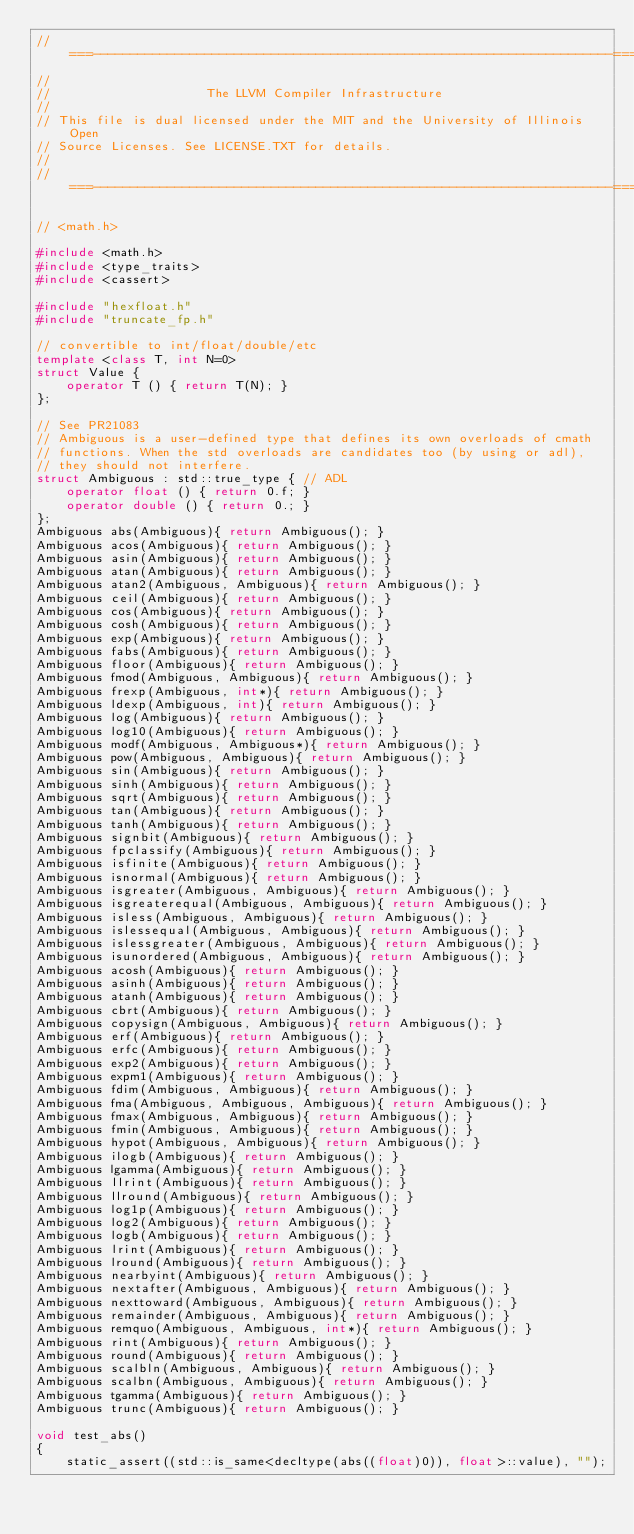<code> <loc_0><loc_0><loc_500><loc_500><_C++_>//===----------------------------------------------------------------------===//
//
//                     The LLVM Compiler Infrastructure
//
// This file is dual licensed under the MIT and the University of Illinois Open
// Source Licenses. See LICENSE.TXT for details.
//
//===----------------------------------------------------------------------===//

// <math.h>

#include <math.h>
#include <type_traits>
#include <cassert>

#include "hexfloat.h"
#include "truncate_fp.h"

// convertible to int/float/double/etc
template <class T, int N=0>
struct Value {
    operator T () { return T(N); }
};

// See PR21083
// Ambiguous is a user-defined type that defines its own overloads of cmath
// functions. When the std overloads are candidates too (by using or adl),
// they should not interfere.
struct Ambiguous : std::true_type { // ADL
    operator float () { return 0.f; }
    operator double () { return 0.; }
};
Ambiguous abs(Ambiguous){ return Ambiguous(); }
Ambiguous acos(Ambiguous){ return Ambiguous(); }
Ambiguous asin(Ambiguous){ return Ambiguous(); }
Ambiguous atan(Ambiguous){ return Ambiguous(); }
Ambiguous atan2(Ambiguous, Ambiguous){ return Ambiguous(); }
Ambiguous ceil(Ambiguous){ return Ambiguous(); }
Ambiguous cos(Ambiguous){ return Ambiguous(); }
Ambiguous cosh(Ambiguous){ return Ambiguous(); }
Ambiguous exp(Ambiguous){ return Ambiguous(); }
Ambiguous fabs(Ambiguous){ return Ambiguous(); }
Ambiguous floor(Ambiguous){ return Ambiguous(); }
Ambiguous fmod(Ambiguous, Ambiguous){ return Ambiguous(); }
Ambiguous frexp(Ambiguous, int*){ return Ambiguous(); }
Ambiguous ldexp(Ambiguous, int){ return Ambiguous(); }
Ambiguous log(Ambiguous){ return Ambiguous(); }
Ambiguous log10(Ambiguous){ return Ambiguous(); }
Ambiguous modf(Ambiguous, Ambiguous*){ return Ambiguous(); }
Ambiguous pow(Ambiguous, Ambiguous){ return Ambiguous(); }
Ambiguous sin(Ambiguous){ return Ambiguous(); }
Ambiguous sinh(Ambiguous){ return Ambiguous(); }
Ambiguous sqrt(Ambiguous){ return Ambiguous(); }
Ambiguous tan(Ambiguous){ return Ambiguous(); }
Ambiguous tanh(Ambiguous){ return Ambiguous(); }
Ambiguous signbit(Ambiguous){ return Ambiguous(); }
Ambiguous fpclassify(Ambiguous){ return Ambiguous(); }
Ambiguous isfinite(Ambiguous){ return Ambiguous(); }
Ambiguous isnormal(Ambiguous){ return Ambiguous(); }
Ambiguous isgreater(Ambiguous, Ambiguous){ return Ambiguous(); }
Ambiguous isgreaterequal(Ambiguous, Ambiguous){ return Ambiguous(); }
Ambiguous isless(Ambiguous, Ambiguous){ return Ambiguous(); }
Ambiguous islessequal(Ambiguous, Ambiguous){ return Ambiguous(); }
Ambiguous islessgreater(Ambiguous, Ambiguous){ return Ambiguous(); }
Ambiguous isunordered(Ambiguous, Ambiguous){ return Ambiguous(); }
Ambiguous acosh(Ambiguous){ return Ambiguous(); }
Ambiguous asinh(Ambiguous){ return Ambiguous(); }
Ambiguous atanh(Ambiguous){ return Ambiguous(); }
Ambiguous cbrt(Ambiguous){ return Ambiguous(); }
Ambiguous copysign(Ambiguous, Ambiguous){ return Ambiguous(); }
Ambiguous erf(Ambiguous){ return Ambiguous(); }
Ambiguous erfc(Ambiguous){ return Ambiguous(); }
Ambiguous exp2(Ambiguous){ return Ambiguous(); }
Ambiguous expm1(Ambiguous){ return Ambiguous(); }
Ambiguous fdim(Ambiguous, Ambiguous){ return Ambiguous(); }
Ambiguous fma(Ambiguous, Ambiguous, Ambiguous){ return Ambiguous(); }
Ambiguous fmax(Ambiguous, Ambiguous){ return Ambiguous(); }
Ambiguous fmin(Ambiguous, Ambiguous){ return Ambiguous(); }
Ambiguous hypot(Ambiguous, Ambiguous){ return Ambiguous(); }
Ambiguous ilogb(Ambiguous){ return Ambiguous(); }
Ambiguous lgamma(Ambiguous){ return Ambiguous(); }
Ambiguous llrint(Ambiguous){ return Ambiguous(); }
Ambiguous llround(Ambiguous){ return Ambiguous(); }
Ambiguous log1p(Ambiguous){ return Ambiguous(); }
Ambiguous log2(Ambiguous){ return Ambiguous(); }
Ambiguous logb(Ambiguous){ return Ambiguous(); }
Ambiguous lrint(Ambiguous){ return Ambiguous(); }
Ambiguous lround(Ambiguous){ return Ambiguous(); }
Ambiguous nearbyint(Ambiguous){ return Ambiguous(); }
Ambiguous nextafter(Ambiguous, Ambiguous){ return Ambiguous(); }
Ambiguous nexttoward(Ambiguous, Ambiguous){ return Ambiguous(); }
Ambiguous remainder(Ambiguous, Ambiguous){ return Ambiguous(); }
Ambiguous remquo(Ambiguous, Ambiguous, int*){ return Ambiguous(); }
Ambiguous rint(Ambiguous){ return Ambiguous(); }
Ambiguous round(Ambiguous){ return Ambiguous(); }
Ambiguous scalbln(Ambiguous, Ambiguous){ return Ambiguous(); }
Ambiguous scalbn(Ambiguous, Ambiguous){ return Ambiguous(); }
Ambiguous tgamma(Ambiguous){ return Ambiguous(); }
Ambiguous trunc(Ambiguous){ return Ambiguous(); }

void test_abs()
{
    static_assert((std::is_same<decltype(abs((float)0)), float>::value), "");</code> 